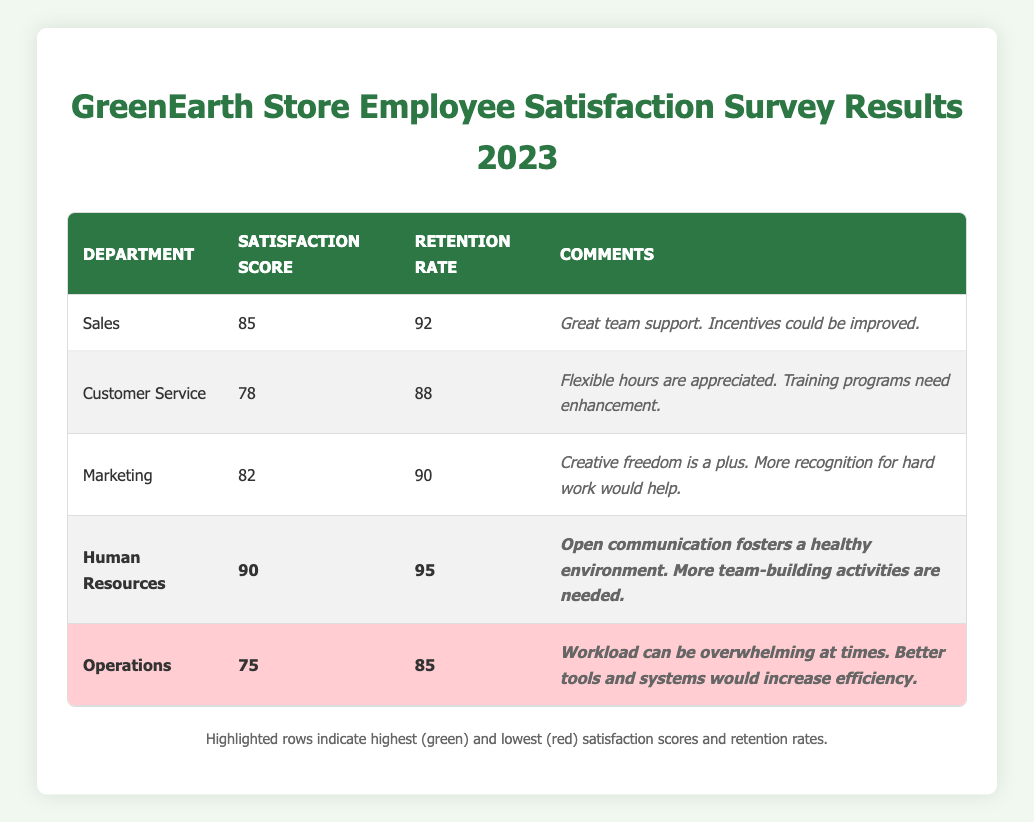What is the highest employee satisfaction score in the survey? The highest satisfaction score is highlighted in green in the table, which is 90, corresponding to the Human Resources department.
Answer: 90 What is the retention rate for the Customer Service department? The retention rate for the Customer Service department is listed directly in the table, which shows 88.
Answer: 88 Which department has the lowest retention rate? The lowest retention rate is highlighted in red in the table, which is 85 for the Operations department.
Answer: Operations What is the average satisfaction score of the Sales and Marketing departments? The satisfaction score for Sales is 85 and for Marketing is 82. Adding them together gives 85 + 82 = 167. To find the average, divide by 2: 167 / 2 = 83.5.
Answer: 83.5 Did the Human Resources department receive any negative comments? Looking at the comments for the Human Resources department in the table, there are no negative remarks listed. Therefore, it is true that there are no negative comments.
Answer: No What is the difference between the retention rates of the Sales and Operations departments? The retention rate for Sales is 92 and for Operations is 85. The difference is calculated by subtracting the lower from the higher: 92 - 85 = 7.
Answer: 7 How many departments scored above 80 in the satisfaction survey? The departments that scored above 80 are Sales (85), Marketing (82), and Human Resources (90). Counting these gives 3 departments.
Answer: 3 What improvements were suggested for the Customer Service department? The comments for the Customer Service department indicate that training programs need enhancement. This is one of the suggested improvements.
Answer: Training programs need enhancement What is the combined satisfaction score for all departments? Adding up all the satisfaction scores: 85 (Sales) + 78 (Customer Service) + 82 (Marketing) + 90 (Human Resources) + 75 (Operations) gives a total of 410.
Answer: 410 Is the retention rate for the Marketing department higher than that of the Customer Service department? The retention rate for Marketing is 90, while for Customer Service it is 88. Since 90 is greater than 88, the statement is true.
Answer: Yes 